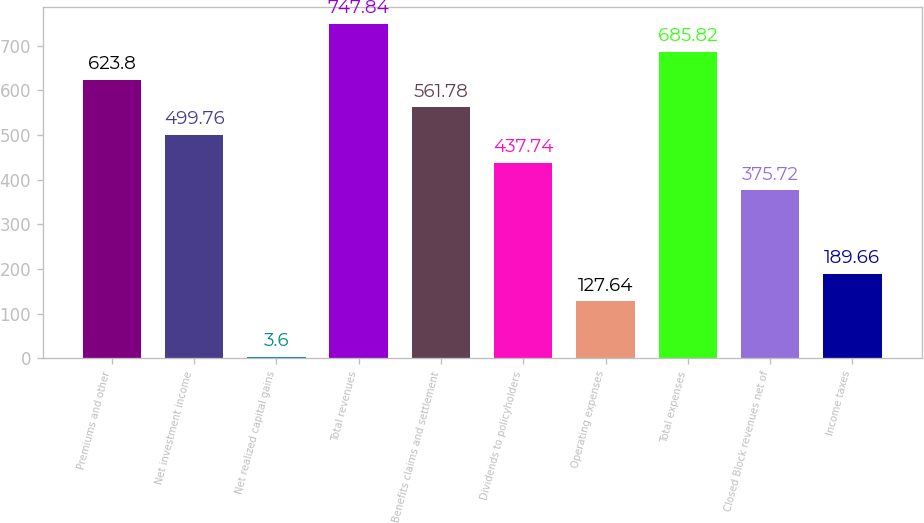<chart> <loc_0><loc_0><loc_500><loc_500><bar_chart><fcel>Premiums and other<fcel>Net investment income<fcel>Net realized capital gains<fcel>Total revenues<fcel>Benefits claims and settlement<fcel>Dividends to policyholders<fcel>Operating expenses<fcel>Total expenses<fcel>Closed Block revenues net of<fcel>Income taxes<nl><fcel>623.8<fcel>499.76<fcel>3.6<fcel>747.84<fcel>561.78<fcel>437.74<fcel>127.64<fcel>685.82<fcel>375.72<fcel>189.66<nl></chart> 